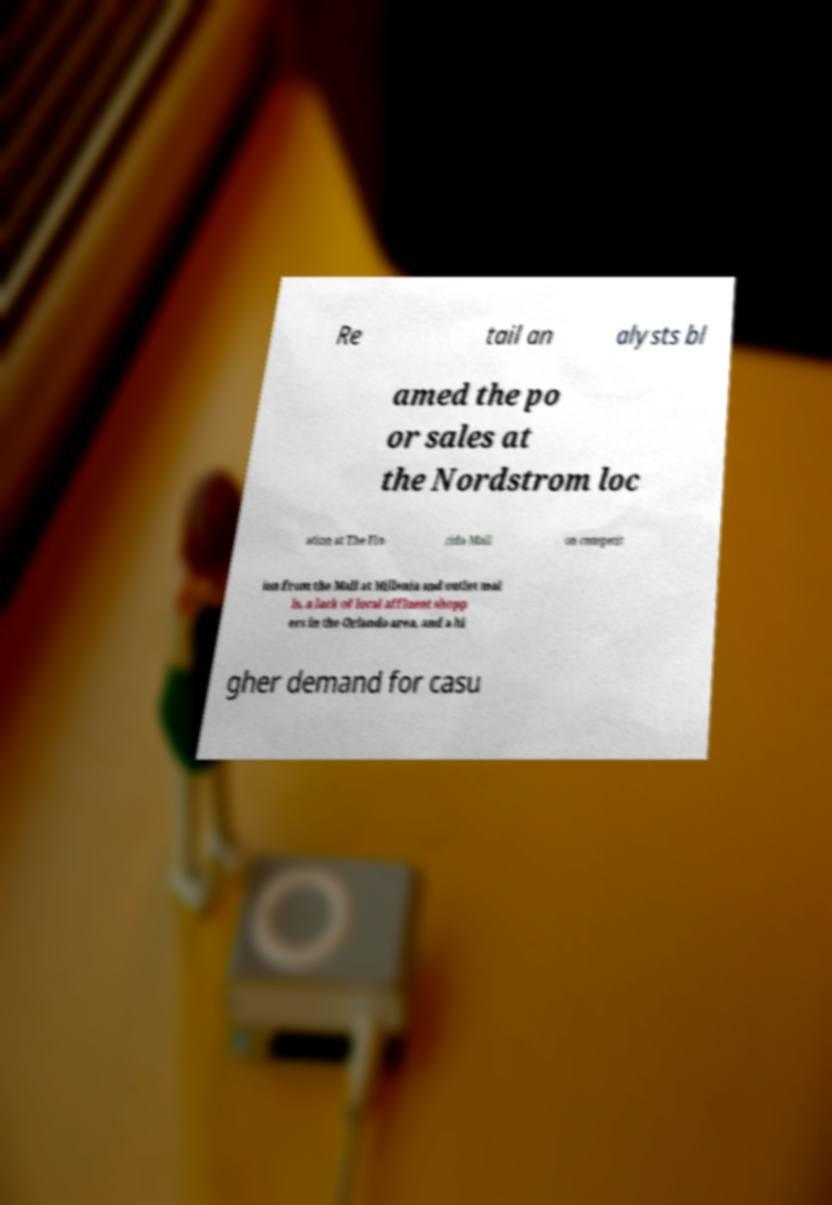What messages or text are displayed in this image? I need them in a readable, typed format. Re tail an alysts bl amed the po or sales at the Nordstrom loc ation at The Flo rida Mall on competit ion from the Mall at Millenia and outlet mal ls, a lack of local affluent shopp ers in the Orlando area, and a hi gher demand for casu 